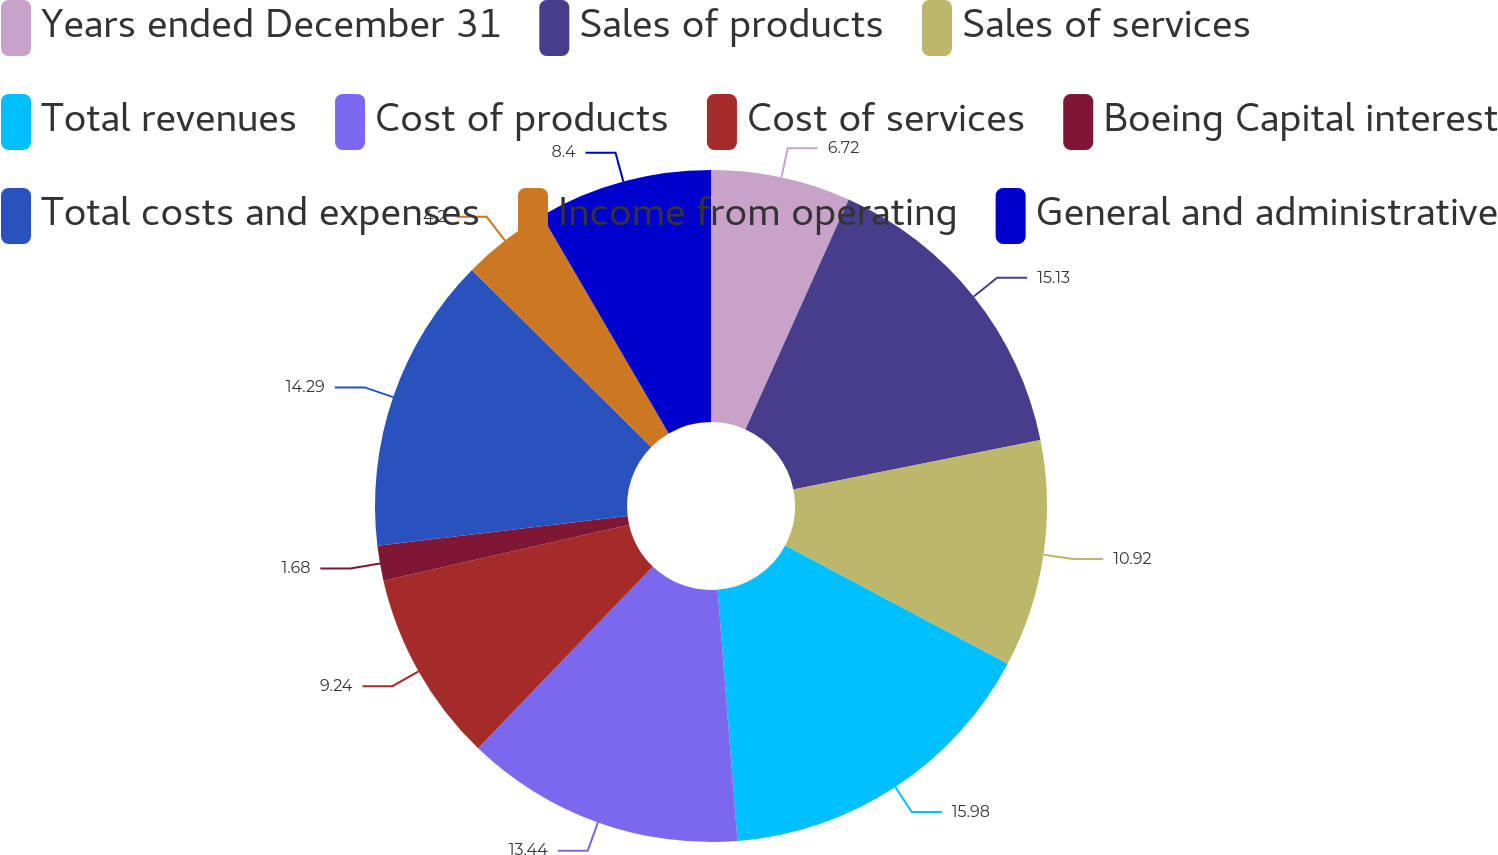Convert chart to OTSL. <chart><loc_0><loc_0><loc_500><loc_500><pie_chart><fcel>Years ended December 31<fcel>Sales of products<fcel>Sales of services<fcel>Total revenues<fcel>Cost of products<fcel>Cost of services<fcel>Boeing Capital interest<fcel>Total costs and expenses<fcel>Income from operating<fcel>General and administrative<nl><fcel>6.72%<fcel>15.13%<fcel>10.92%<fcel>15.97%<fcel>13.44%<fcel>9.24%<fcel>1.68%<fcel>14.29%<fcel>4.2%<fcel>8.4%<nl></chart> 